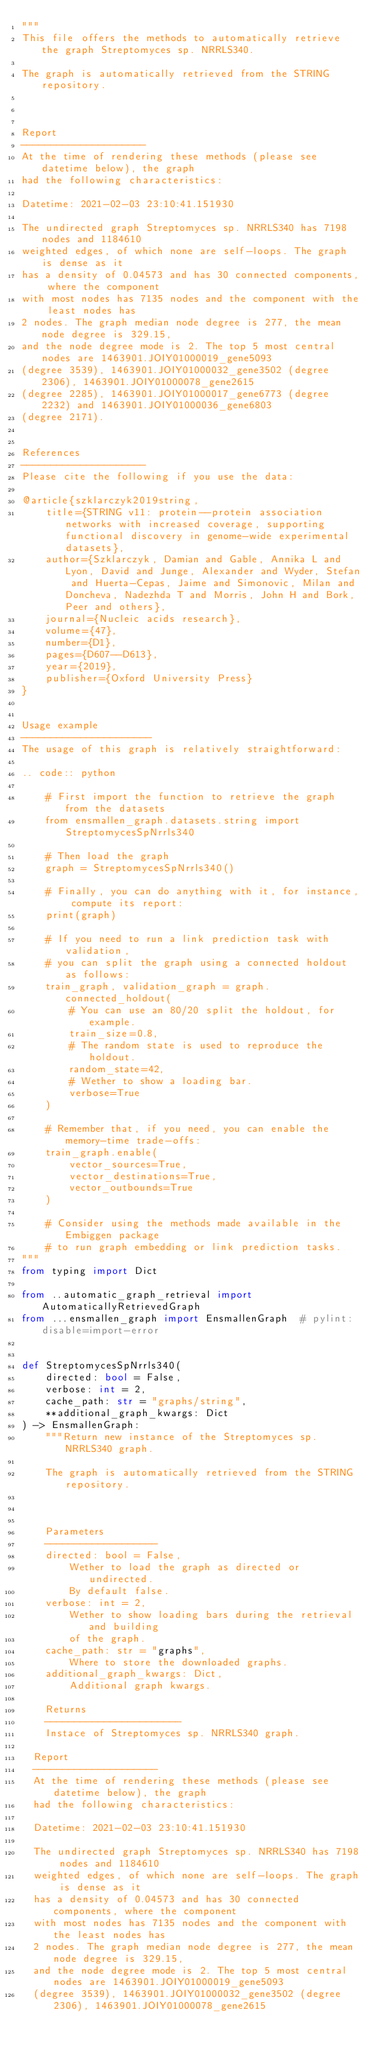Convert code to text. <code><loc_0><loc_0><loc_500><loc_500><_Python_>"""
This file offers the methods to automatically retrieve the graph Streptomyces sp. NRRLS340.

The graph is automatically retrieved from the STRING repository. 



Report
---------------------
At the time of rendering these methods (please see datetime below), the graph
had the following characteristics:

Datetime: 2021-02-03 23:10:41.151930

The undirected graph Streptomyces sp. NRRLS340 has 7198 nodes and 1184610
weighted edges, of which none are self-loops. The graph is dense as it
has a density of 0.04573 and has 30 connected components, where the component
with most nodes has 7135 nodes and the component with the least nodes has
2 nodes. The graph median node degree is 277, the mean node degree is 329.15,
and the node degree mode is 2. The top 5 most central nodes are 1463901.JOIY01000019_gene5093
(degree 3539), 1463901.JOIY01000032_gene3502 (degree 2306), 1463901.JOIY01000078_gene2615
(degree 2285), 1463901.JOIY01000017_gene6773 (degree 2232) and 1463901.JOIY01000036_gene6803
(degree 2171).


References
---------------------
Please cite the following if you use the data:

@article{szklarczyk2019string,
    title={STRING v11: protein--protein association networks with increased coverage, supporting functional discovery in genome-wide experimental datasets},
    author={Szklarczyk, Damian and Gable, Annika L and Lyon, David and Junge, Alexander and Wyder, Stefan and Huerta-Cepas, Jaime and Simonovic, Milan and Doncheva, Nadezhda T and Morris, John H and Bork, Peer and others},
    journal={Nucleic acids research},
    volume={47},
    number={D1},
    pages={D607--D613},
    year={2019},
    publisher={Oxford University Press}
}


Usage example
----------------------
The usage of this graph is relatively straightforward:

.. code:: python

    # First import the function to retrieve the graph from the datasets
    from ensmallen_graph.datasets.string import StreptomycesSpNrrls340

    # Then load the graph
    graph = StreptomycesSpNrrls340()

    # Finally, you can do anything with it, for instance, compute its report:
    print(graph)

    # If you need to run a link prediction task with validation,
    # you can split the graph using a connected holdout as follows:
    train_graph, validation_graph = graph.connected_holdout(
        # You can use an 80/20 split the holdout, for example.
        train_size=0.8,
        # The random state is used to reproduce the holdout.
        random_state=42,
        # Wether to show a loading bar.
        verbose=True
    )

    # Remember that, if you need, you can enable the memory-time trade-offs:
    train_graph.enable(
        vector_sources=True,
        vector_destinations=True,
        vector_outbounds=True
    )

    # Consider using the methods made available in the Embiggen package
    # to run graph embedding or link prediction tasks.
"""
from typing import Dict

from ..automatic_graph_retrieval import AutomaticallyRetrievedGraph
from ...ensmallen_graph import EnsmallenGraph  # pylint: disable=import-error


def StreptomycesSpNrrls340(
    directed: bool = False,
    verbose: int = 2,
    cache_path: str = "graphs/string",
    **additional_graph_kwargs: Dict
) -> EnsmallenGraph:
    """Return new instance of the Streptomyces sp. NRRLS340 graph.

    The graph is automatically retrieved from the STRING repository. 

	

    Parameters
    -------------------
    directed: bool = False,
        Wether to load the graph as directed or undirected.
        By default false.
    verbose: int = 2,
        Wether to show loading bars during the retrieval and building
        of the graph.
    cache_path: str = "graphs",
        Where to store the downloaded graphs.
    additional_graph_kwargs: Dict,
        Additional graph kwargs.

    Returns
    -----------------------
    Instace of Streptomyces sp. NRRLS340 graph.

	Report
	---------------------
	At the time of rendering these methods (please see datetime below), the graph
	had the following characteristics:
	
	Datetime: 2021-02-03 23:10:41.151930
	
	The undirected graph Streptomyces sp. NRRLS340 has 7198 nodes and 1184610
	weighted edges, of which none are self-loops. The graph is dense as it
	has a density of 0.04573 and has 30 connected components, where the component
	with most nodes has 7135 nodes and the component with the least nodes has
	2 nodes. The graph median node degree is 277, the mean node degree is 329.15,
	and the node degree mode is 2. The top 5 most central nodes are 1463901.JOIY01000019_gene5093
	(degree 3539), 1463901.JOIY01000032_gene3502 (degree 2306), 1463901.JOIY01000078_gene2615</code> 